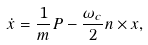<formula> <loc_0><loc_0><loc_500><loc_500>\dot { x } = \frac { 1 } { m } { P } - \frac { \omega _ { c } } { 2 } { n } \times x ,</formula> 